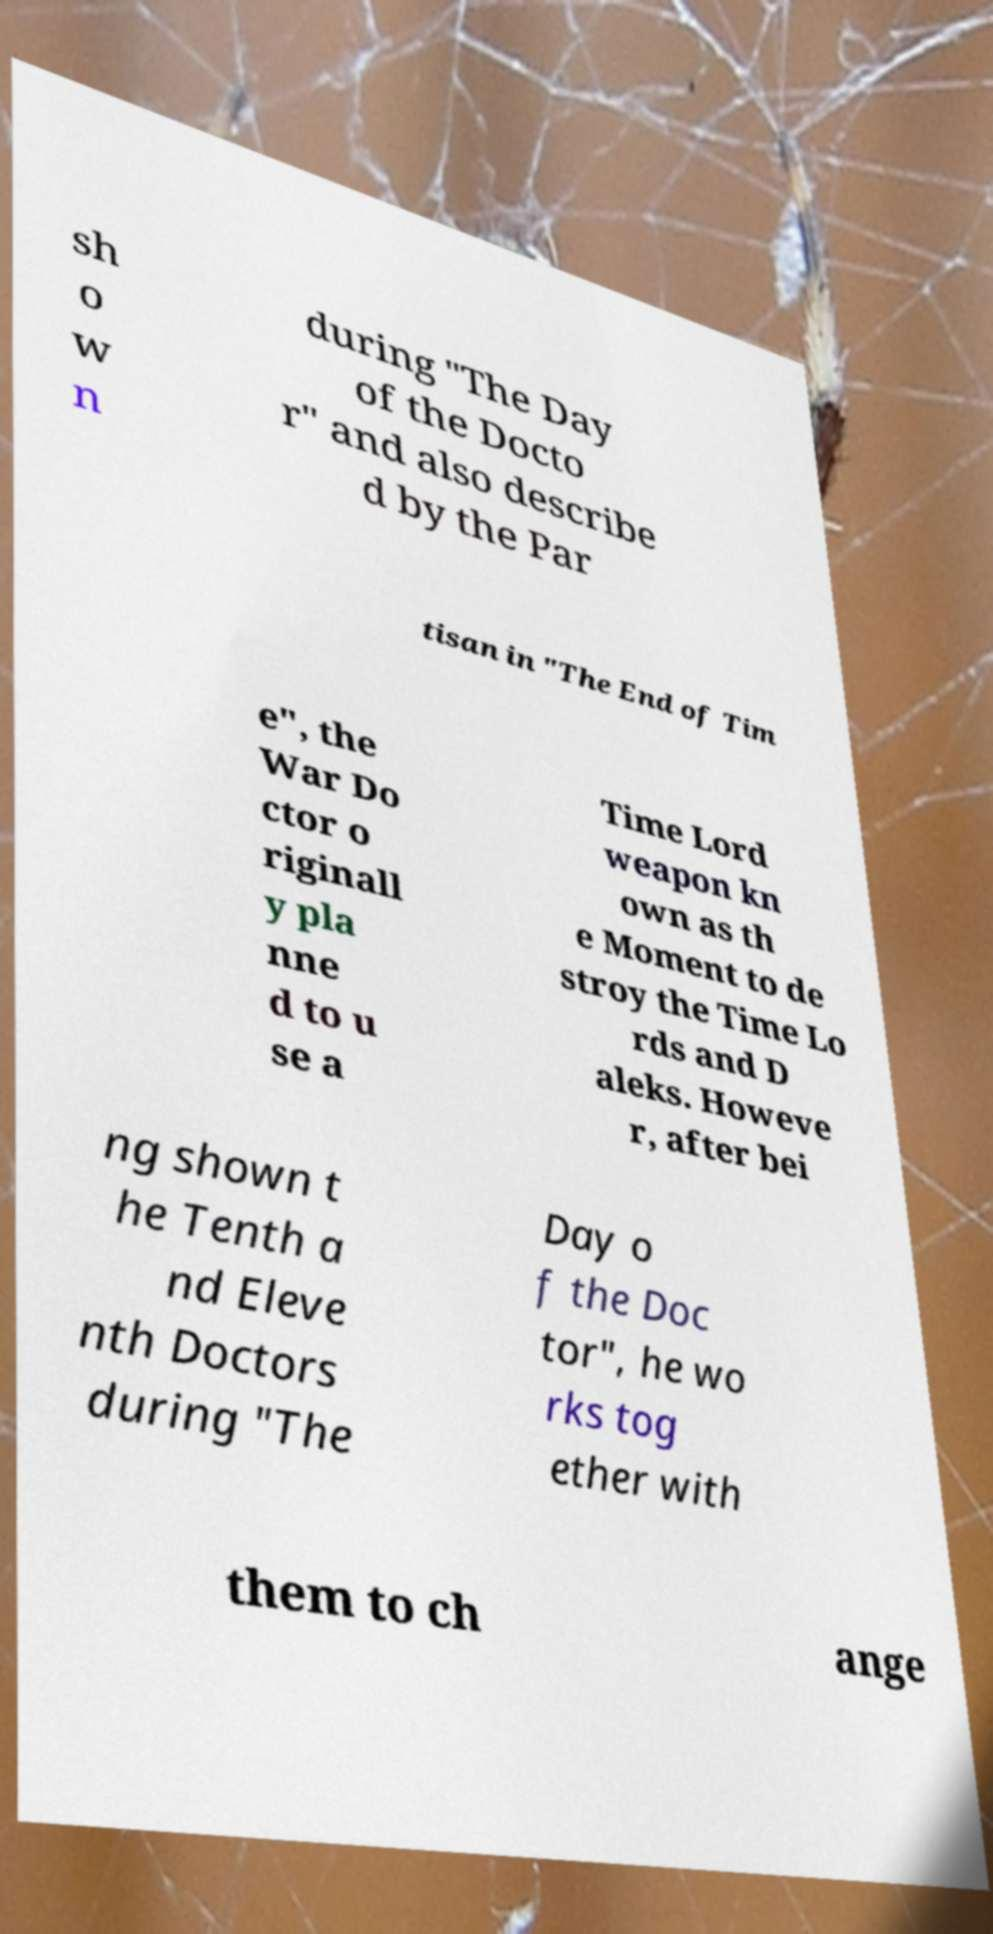Please identify and transcribe the text found in this image. sh o w n during "The Day of the Docto r" and also describe d by the Par tisan in "The End of Tim e", the War Do ctor o riginall y pla nne d to u se a Time Lord weapon kn own as th e Moment to de stroy the Time Lo rds and D aleks. Howeve r, after bei ng shown t he Tenth a nd Eleve nth Doctors during "The Day o f the Doc tor", he wo rks tog ether with them to ch ange 